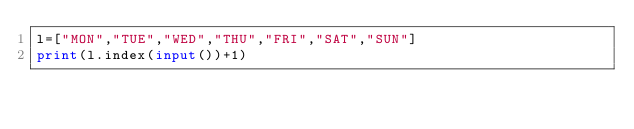Convert code to text. <code><loc_0><loc_0><loc_500><loc_500><_Python_>l=["MON","TUE","WED","THU","FRI","SAT","SUN"]
print(l.index(input())+1)</code> 